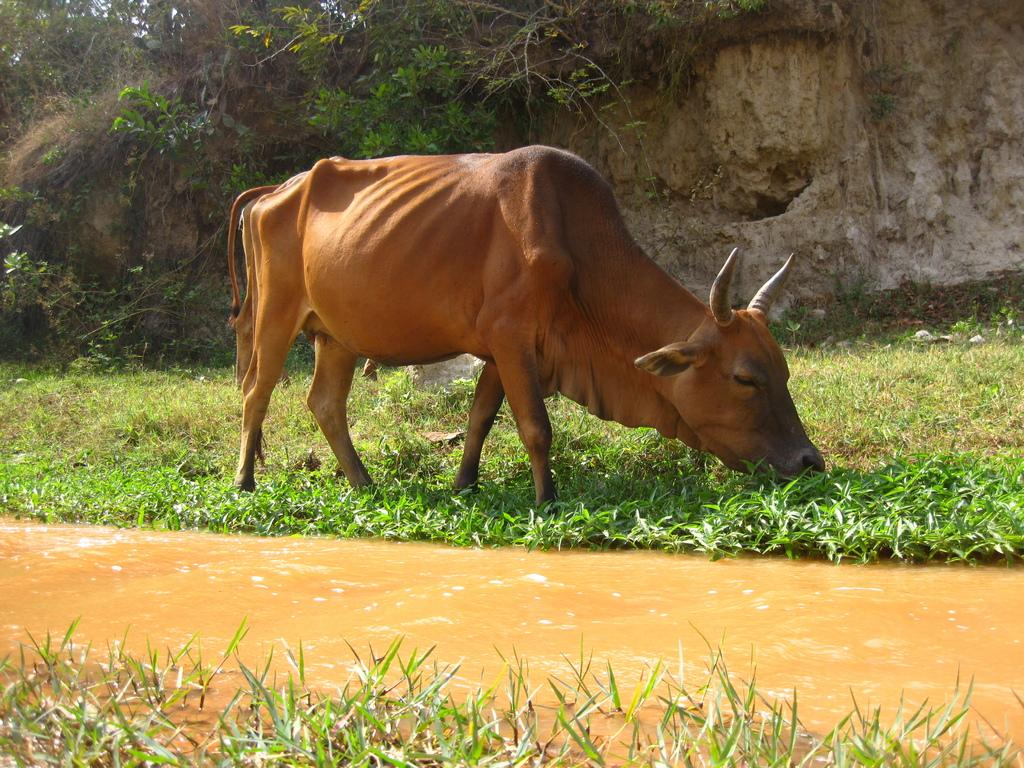What type of animal can be seen in the image? There is an animal in the image, and it is brown in color. What is the primary element visible in the image? Water is visible in the image. What can be seen in the background of the image? There is grass and plants in the background of the image. What color are the plants in the image? The plants in the image are green in color. What is the color of the sky in the image? The sky is white in color. What type of cast can be seen on the animal's leg in the image? There is no cast visible on the animal's leg in the image. What type of fowl is present in the image? There is no fowl present in the image; the main subject is a brown animal. What type of pump is visible in the image? There is no pump present in the image. 